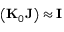Convert formula to latex. <formula><loc_0><loc_0><loc_500><loc_500>\left ( { K } _ { 0 } { J } \right ) \approx { I }</formula> 